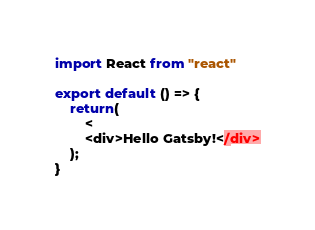Convert code to text. <code><loc_0><loc_0><loc_500><loc_500><_JavaScript_>import React from "react"

export default () => {
    return(
        <
        <div>Hello Gatsby!</div>
    );
}
</code> 